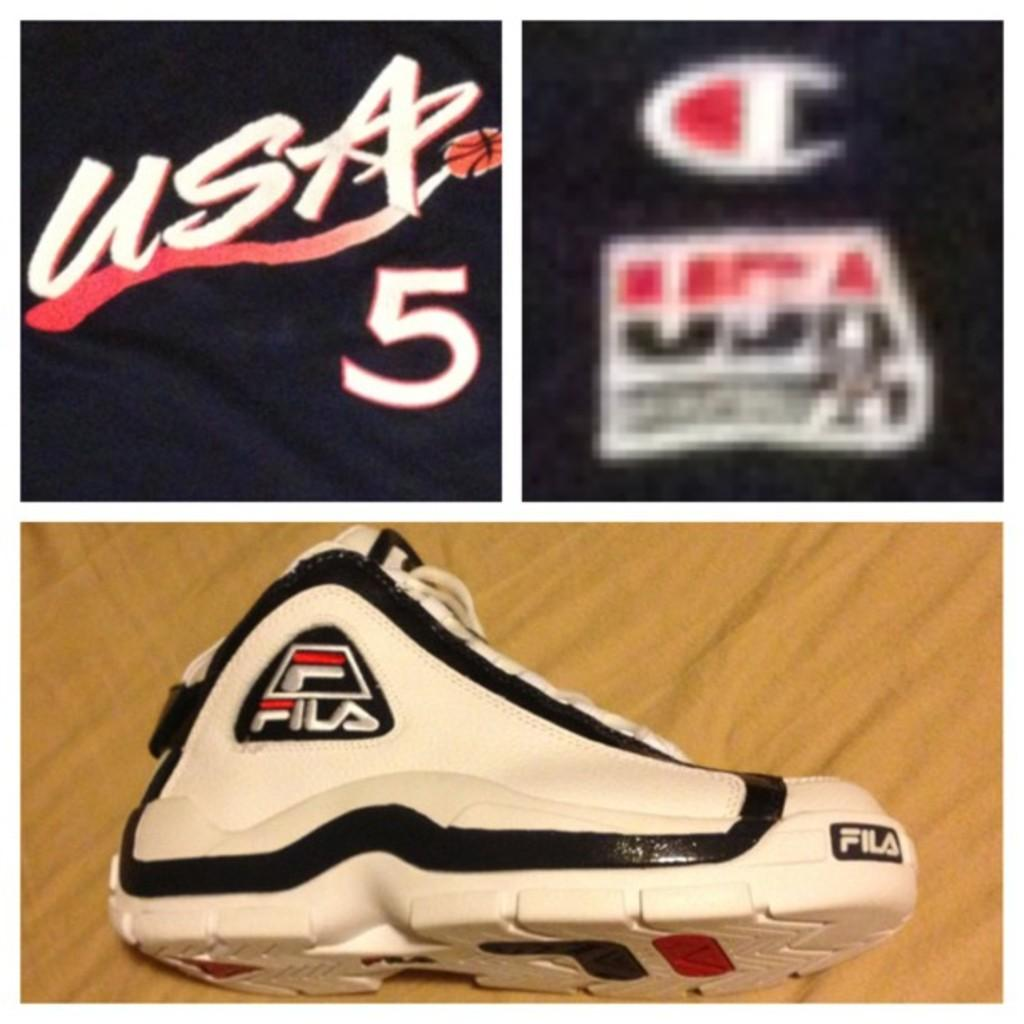<image>
Relay a brief, clear account of the picture shown. a shoe with a Fila logo on it 